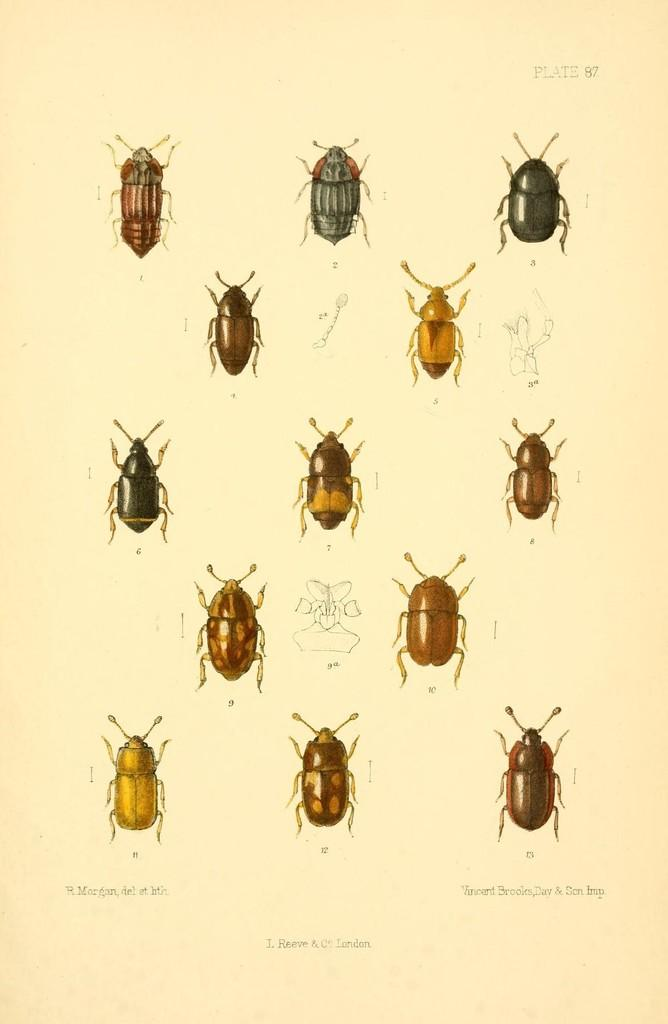What type of creatures are depicted on the paper in the image? The paper in the image contains pictures of different insects. What else can be found on the paper besides the insect images? There is text on the paper. How many rabbits can be seen in the image? There are no rabbits present in the image; it features pictures of insects and text on a paper. What type of appliance is visible in the image? There is no appliance visible in the image; it only contains a paper with insect pictures and text. 